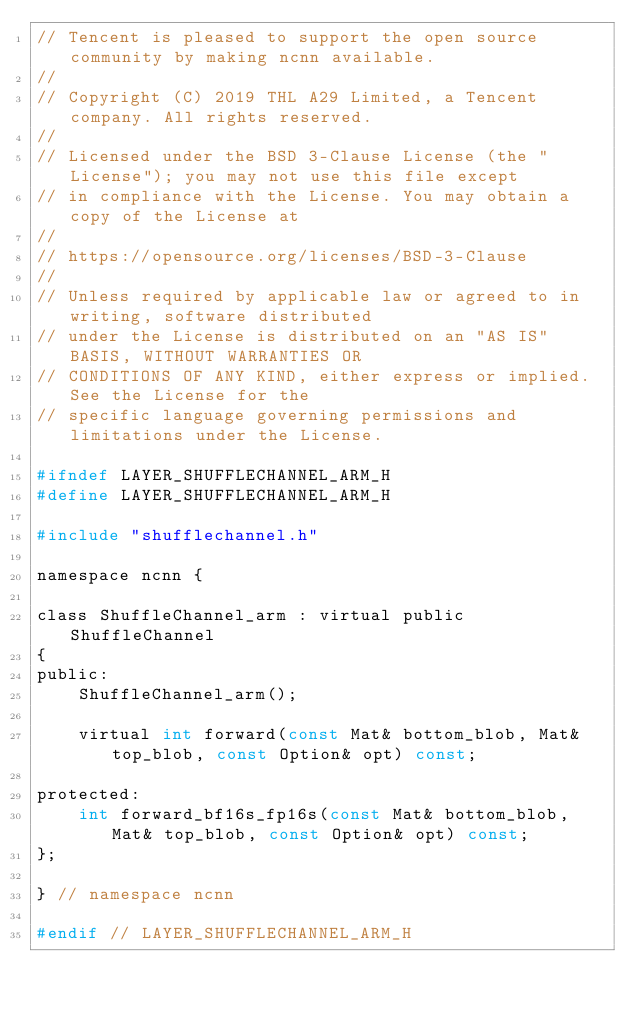<code> <loc_0><loc_0><loc_500><loc_500><_C_>// Tencent is pleased to support the open source community by making ncnn available.
//
// Copyright (C) 2019 THL A29 Limited, a Tencent company. All rights reserved.
//
// Licensed under the BSD 3-Clause License (the "License"); you may not use this file except
// in compliance with the License. You may obtain a copy of the License at
//
// https://opensource.org/licenses/BSD-3-Clause
//
// Unless required by applicable law or agreed to in writing, software distributed
// under the License is distributed on an "AS IS" BASIS, WITHOUT WARRANTIES OR
// CONDITIONS OF ANY KIND, either express or implied. See the License for the
// specific language governing permissions and limitations under the License.

#ifndef LAYER_SHUFFLECHANNEL_ARM_H
#define LAYER_SHUFFLECHANNEL_ARM_H

#include "shufflechannel.h"

namespace ncnn {

class ShuffleChannel_arm : virtual public ShuffleChannel
{
public:
    ShuffleChannel_arm();

    virtual int forward(const Mat& bottom_blob, Mat& top_blob, const Option& opt) const;

protected:
    int forward_bf16s_fp16s(const Mat& bottom_blob, Mat& top_blob, const Option& opt) const;
};

} // namespace ncnn

#endif // LAYER_SHUFFLECHANNEL_ARM_H
</code> 